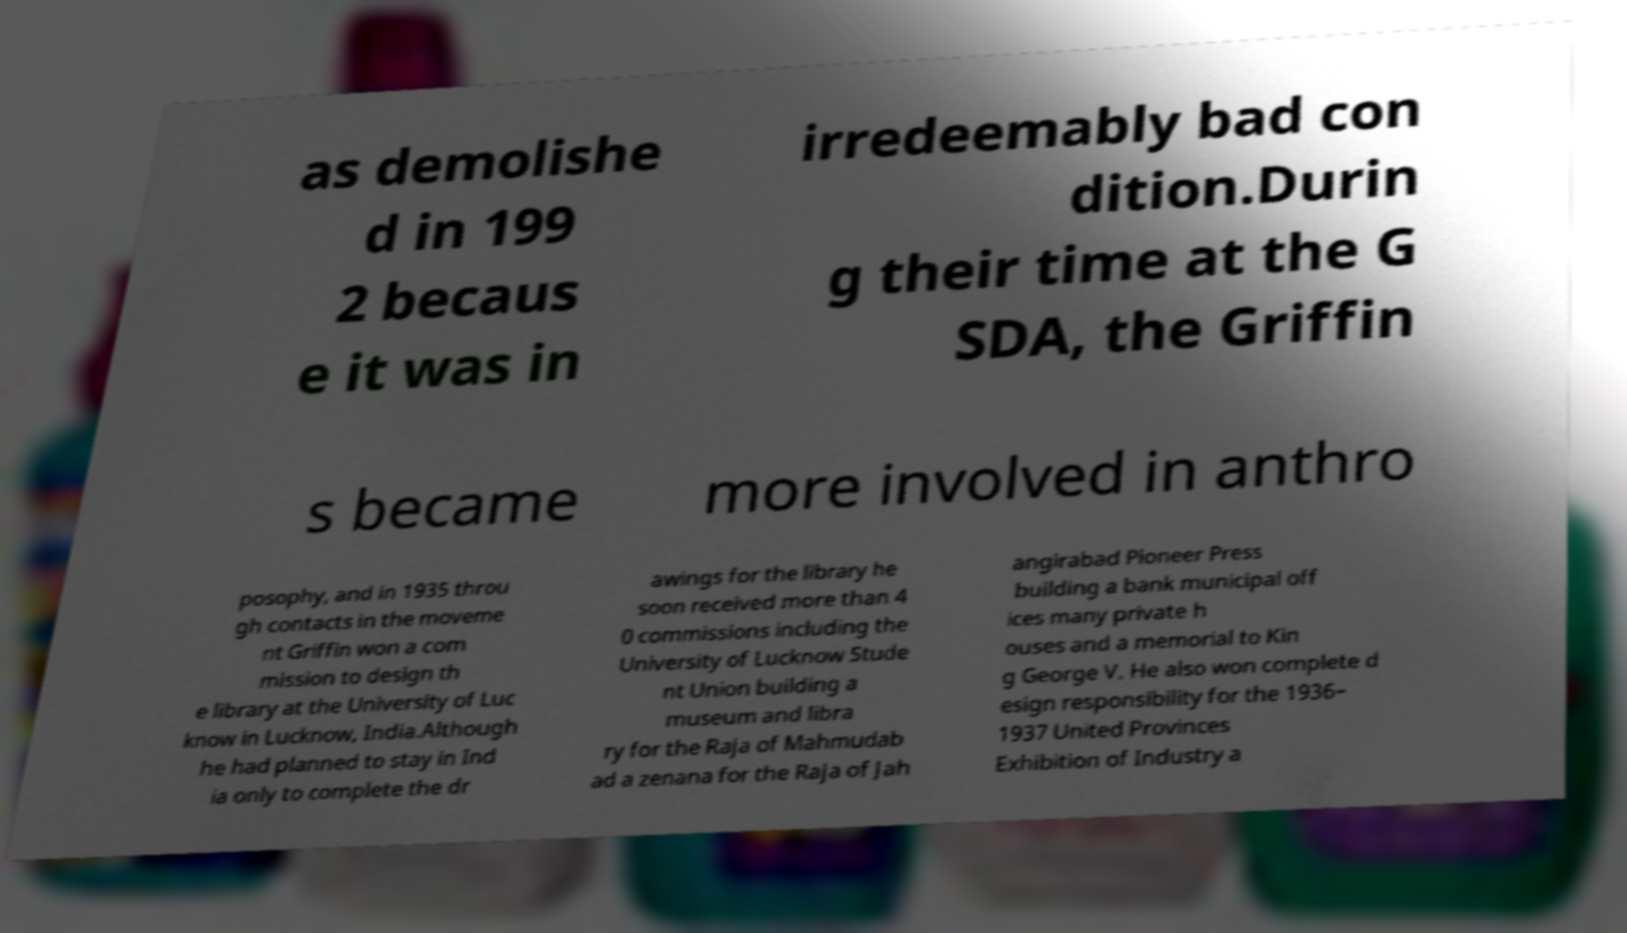Please identify and transcribe the text found in this image. as demolishe d in 199 2 becaus e it was in irredeemably bad con dition.Durin g their time at the G SDA, the Griffin s became more involved in anthro posophy, and in 1935 throu gh contacts in the moveme nt Griffin won a com mission to design th e library at the University of Luc know in Lucknow, India.Although he had planned to stay in Ind ia only to complete the dr awings for the library he soon received more than 4 0 commissions including the University of Lucknow Stude nt Union building a museum and libra ry for the Raja of Mahmudab ad a zenana for the Raja of Jah angirabad Pioneer Press building a bank municipal off ices many private h ouses and a memorial to Kin g George V. He also won complete d esign responsibility for the 1936– 1937 United Provinces Exhibition of Industry a 